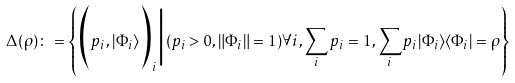Convert formula to latex. <formula><loc_0><loc_0><loc_500><loc_500>\Delta ( \rho ) \colon = \left \{ \Big ( p _ { i } , | \Phi _ { i } \rangle \Big ) _ { i } \Big | ( p _ { i } > 0 , \| \Phi _ { i } \| = 1 ) \forall i , \sum _ { i } p _ { i } = 1 , \sum _ { i } p _ { i } | \Phi _ { i } \rangle \langle \Phi _ { i } | = \rho \right \}</formula> 